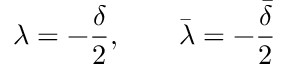Convert formula to latex. <formula><loc_0><loc_0><loc_500><loc_500>\lambda = - \frac { \delta } { 2 } , \bar { \lambda } = - \frac { \bar { \delta } } { 2 }</formula> 